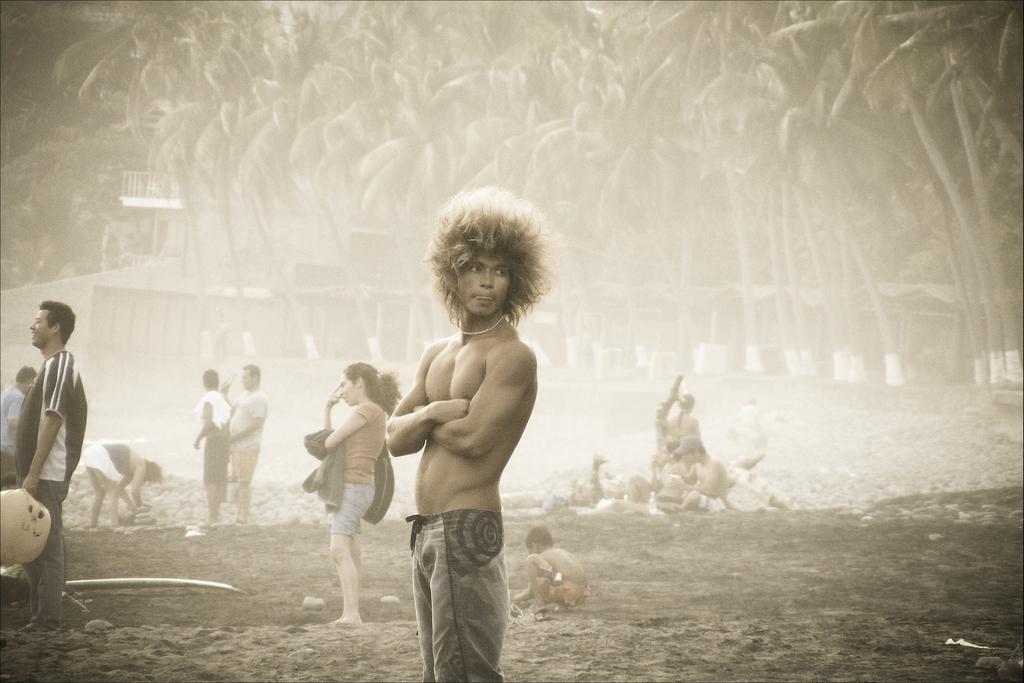Please provide a concise description of this image. In this image we can see people. In the background there are trees and sheds. 